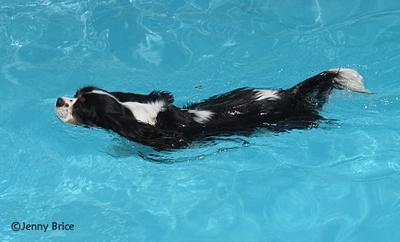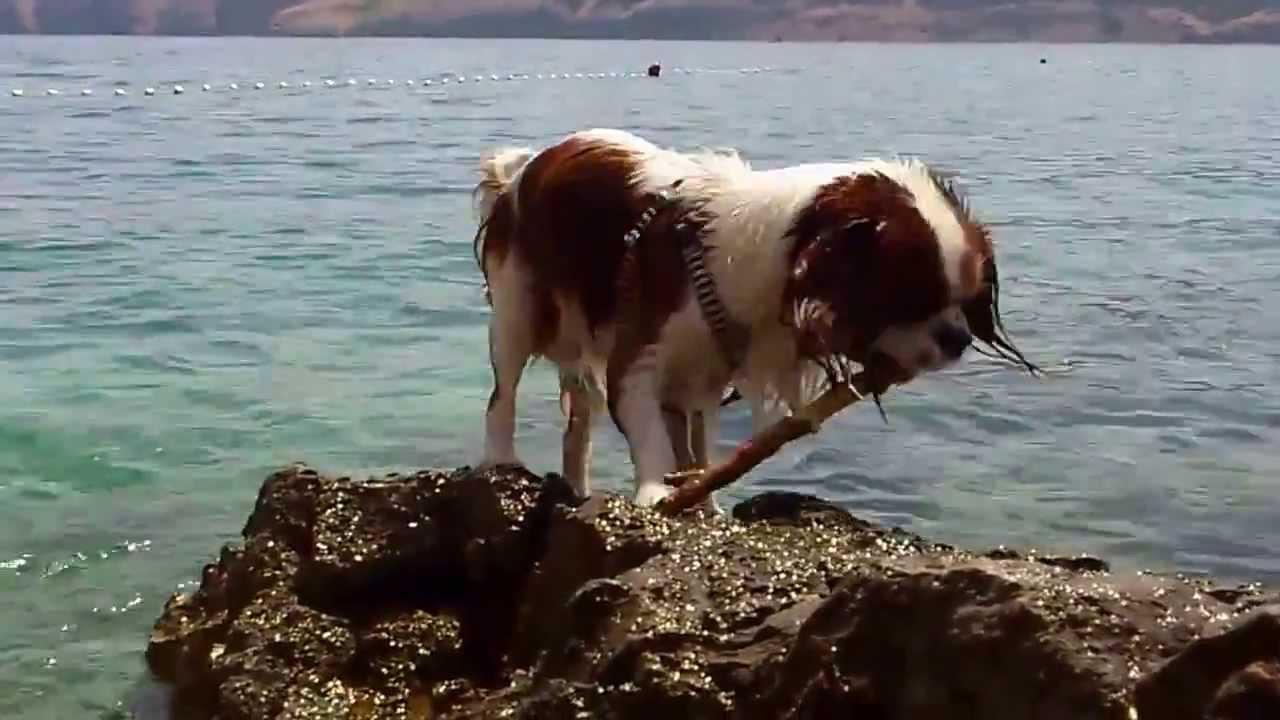The first image is the image on the left, the second image is the image on the right. Considering the images on both sides, is "The righthand image shows a spaniel with a natural body of water, and the lefthand shows a spaniel in pool water." valid? Answer yes or no. Yes. The first image is the image on the left, the second image is the image on the right. For the images shown, is this caption "There is a dog swimming in each image." true? Answer yes or no. No. 